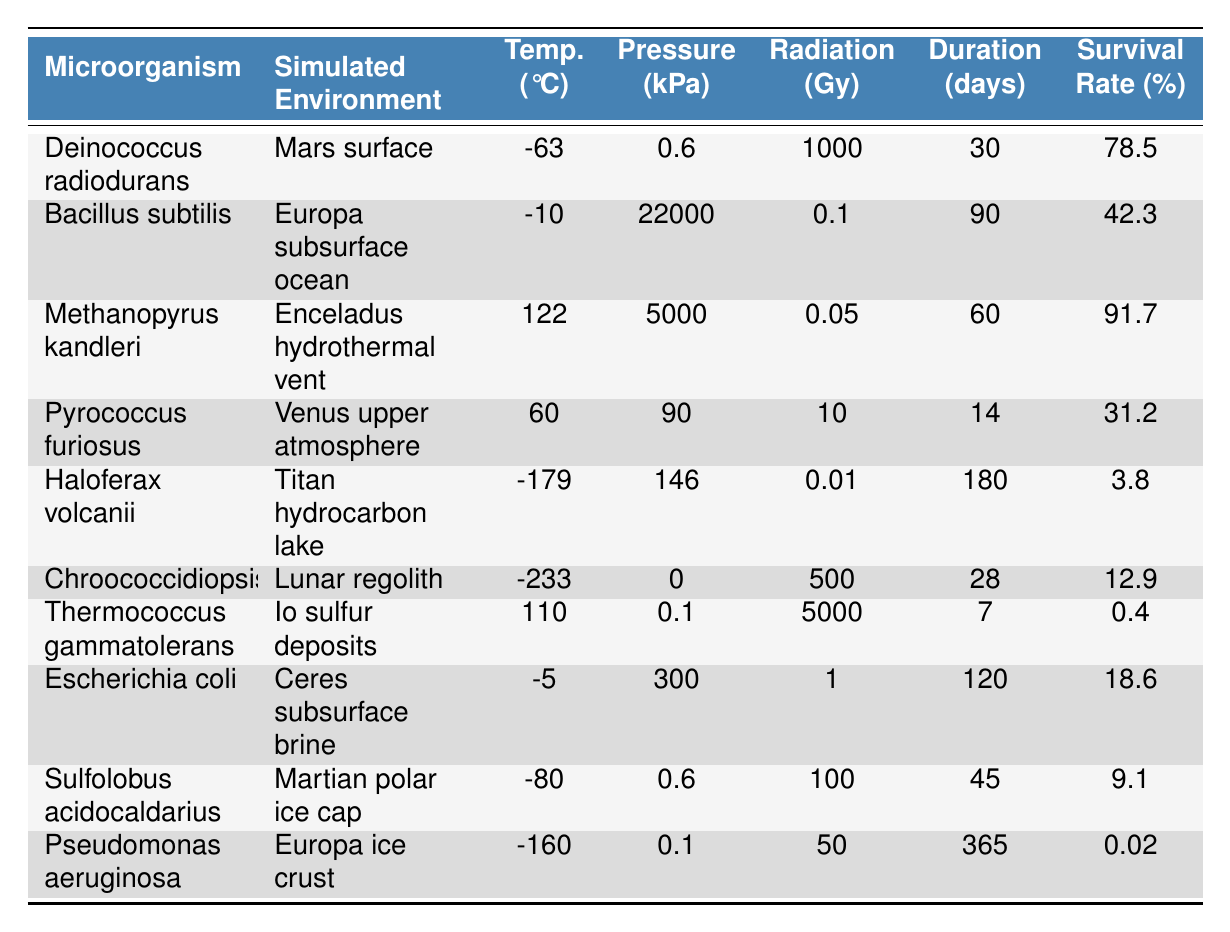What microorganism has the highest survival rate in the simulated environments? From the table, we can check the 'Survival Rate (%)' column to find the highest value. The highest survival rate is 91.7%, associated with Methanopyrus kandleri in the Enceladus hydrothermal vent environment.
Answer: Methanopyrus kandleri Which microorganism experienced the lowest survival rate, and what was that rate? Looking at the 'Survival Rate (%)' column, the lowest value is 0.02% for Pseudomonas aeruginosa in the Europa ice crust environment.
Answer: Pseudomonas aeruginosa, 0.02% What is the average survival rate of the microorganisms tested in Martian environments? The relevant microorganisms are Deinococcus radiodurans (78.5%) and Sulfolobus acidocaldarius (9.1%). The sum of the survival rates is 78.5 + 9.1 = 87.6%. There are 2 values, so the average is 87.6 / 2 = 43.8%.
Answer: 43.8% Is it true that all microorganisms in extreme environments (temperature below -150 °C) have a survival rate above 10%? Two microorganisms are below -150 °C: Haloferax volcanii (3.8%) and Pseudomonas aeruginosa (0.02%). Since both have survival rates below 10%, the statement is false.
Answer: False What is the difference in survival rates between the organisms from the hottest and the coldest environments? The hottest environment is the Enceladus hydrothermal vent with Methanopyrus kandleri (91.7%), while the coldest is the Lunar regolith with Chroococcidiopsis (12.9%). The difference is 91.7 - 12.9 = 78.8%.
Answer: 78.8% How many days did the microorganism Haloferax volcanii survive in its environment? The table shows that Haloferax volcanii survived for 180 days in the Titan hydrocarbon lake environment.
Answer: 180 days Which microorganism has the highest radiation exposure, and what was the survival rate for that organism? The organism with the highest radiation exposure of 1000 Gy is Deinococcus radiodurans, which has a survival rate of 78.5%.
Answer: Deinococcus radiodurans, 78.5% If we consider only the organisms with survival rates above 40%, what is the median survival rate among them? The organisms above 40% are Methanopyrus kandleri (91.7%), Deinococcus radiodurans (78.5%), and Bacillus subtilis (42.3%). The survival rates sorted are 42.3%, 78.5%, and 91.7%. The median is 78.5% (the middle value).
Answer: 78.5% How many microorganisms were tested under the simulated Europa environments, and what is their average survival rate? Two microorganisms are under simulated Europa environments: Bacillus subtilis (42.3%) and Pseudomonas aeruginosa (0.02%). The sum is 42.3 + 0.02 = 42.32% and average is 42.32 / 2 = 21.16%.
Answer: 2 microorganisms, 21.16% average survival rate Which environment shows the greatest range in temperature among the microorganisms? The environments with the highest and lowest temperatures are: Methanopyrus kandleri (122 °C) and Chroococcidiopsis (-233 °C). The range is 122 - (-233) = 355 °C.
Answer: 355 °C range 